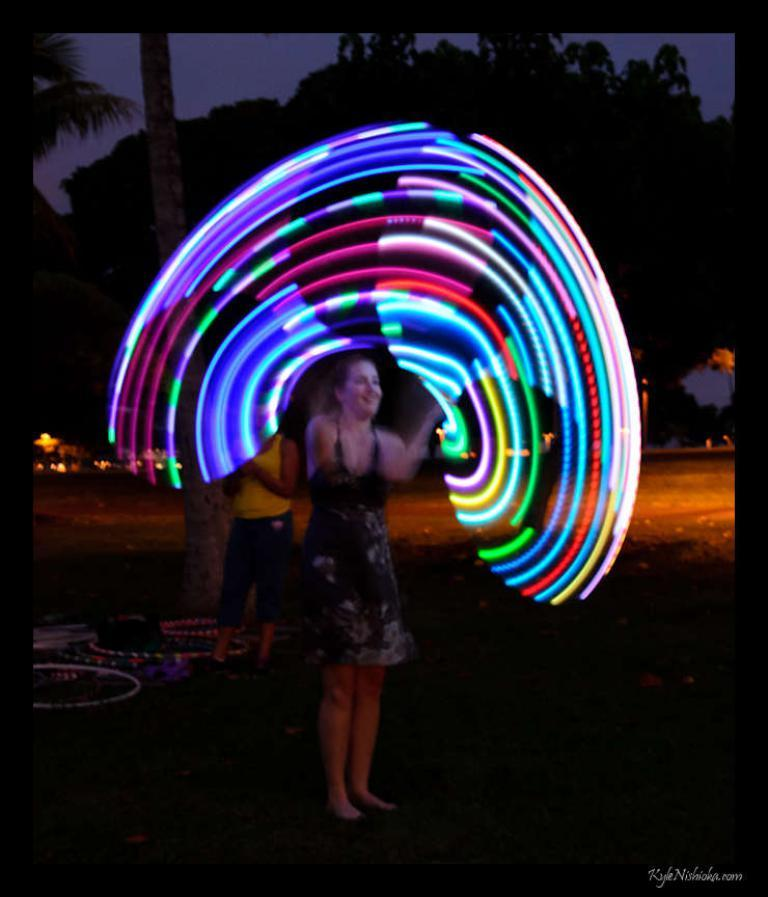How many people are in the image? There are two persons in the image. What are the people doing in the image? We cannot determine their exact actions from the provided facts, but we know that one person is holding an object. What can be seen on the ground in the image? There are objects on the ground in the image. What is visible in the background of the image? There are trees and the sky visible in the background of the image. What type of kitten is performing in the show in the image? There is no kitten or show present in the image; it features two persons and objects on the ground. 